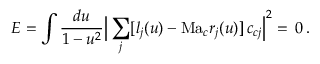Convert formula to latex. <formula><loc_0><loc_0><loc_500><loc_500>E = \int \frac { d { u } } { 1 - u ^ { 2 } } \left | \sum _ { j } [ l _ { j } ( u ) - M a _ { c } r _ { j } ( u ) ] \, c _ { c j } \right | ^ { 2 } = \, 0 \, .</formula> 